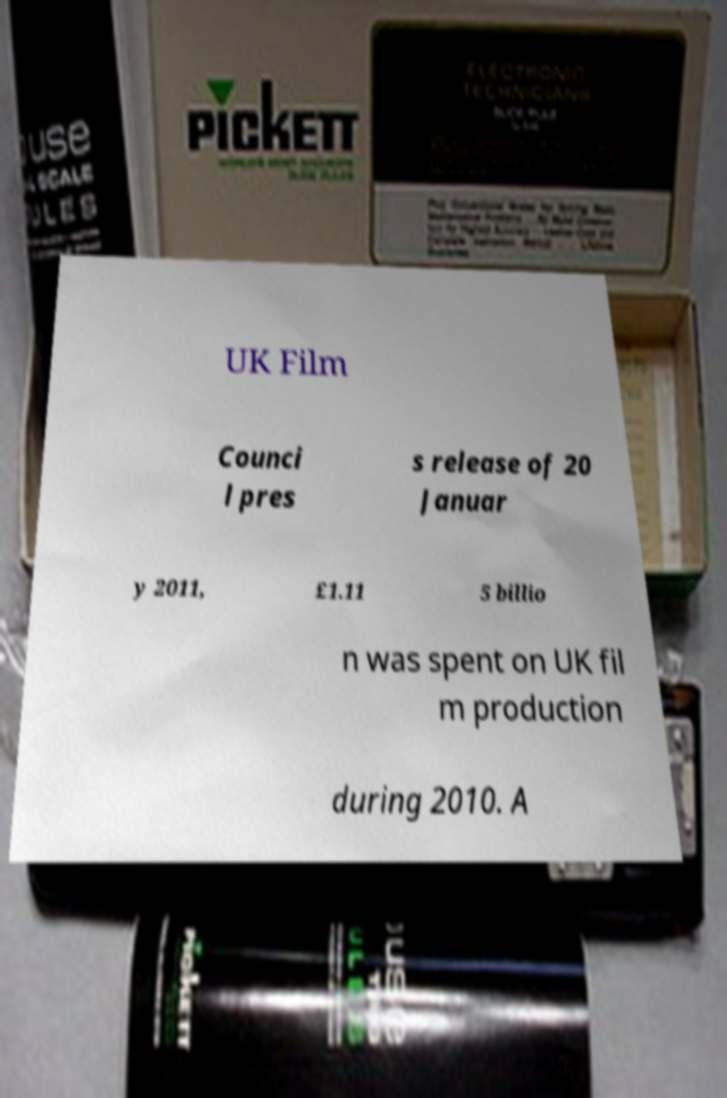I need the written content from this picture converted into text. Can you do that? UK Film Counci l pres s release of 20 Januar y 2011, £1.11 5 billio n was spent on UK fil m production during 2010. A 